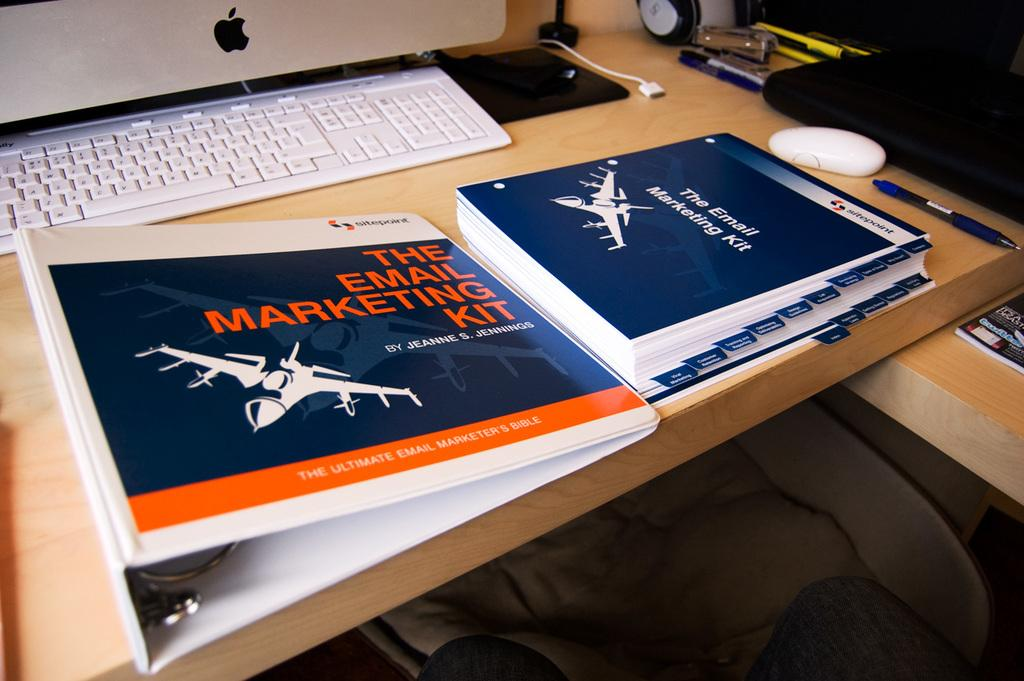What piece of furniture is present in the image? There is a table in the image. What items can be seen on the table? There are books, a mouse, a pen, a keyboard, and a monitor on the table. What is the purpose of the chair in the image? The chair is under the table, likely for someone to sit on while using the table. Where is the glove placed on the table in the image? There is no glove present in the image. What time is displayed on the clock in the image? There is no clock present in the image. 